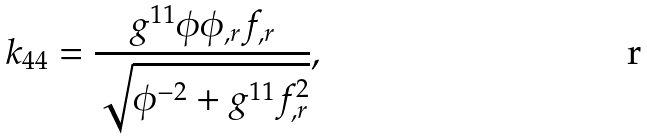Convert formula to latex. <formula><loc_0><loc_0><loc_500><loc_500>k _ { 4 4 } = \frac { g ^ { 1 1 } \phi \phi _ { , r } f _ { , r } } { \sqrt { \phi ^ { - 2 } + g ^ { 1 1 } f _ { , r } ^ { 2 } } } ,</formula> 